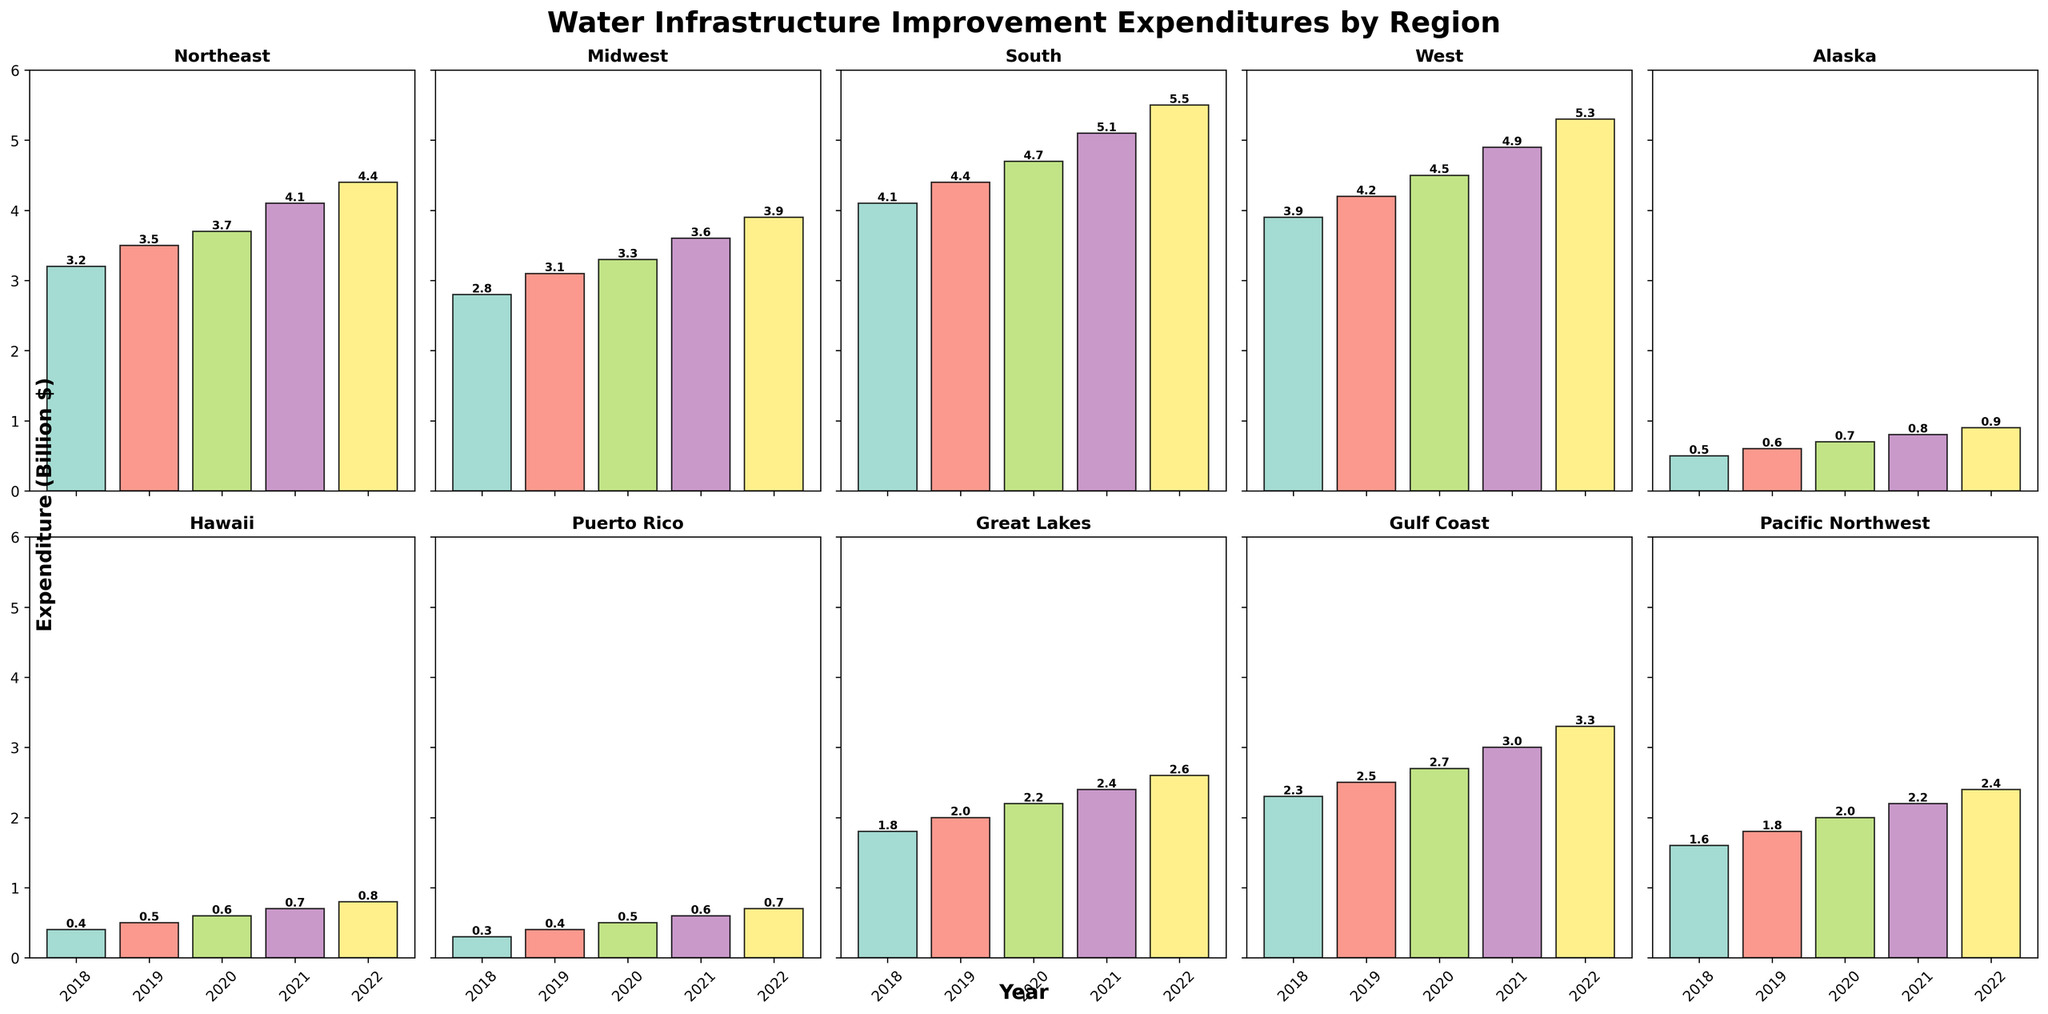Which region had the highest expenditure on water infrastructure improvements in 2022? To find the region with the highest expenditure in 2022, look at the height of the bars representing 2022 in all subplots. The tallest bar represents the highest expenditure. In the 2022 subplot, the South region has the tallest bar reaching 5.5.
Answer: South Which region had the lowest average expenditure from 2018 to 2022? Calculate the average expenditure for each region by summing the 2018-2022 values and dividing by 5. Then compare all averages. For example, for Alaska: (0.5 + 0.6 + 0.7 + 0.8 + 0.9) / 5 = 0.7, and do the same for all regions. The average for Puerto Rico is the lowest at (0.3 + 0.4 + 0.5 + 0.6 + 0.7)/5 = 0.5.
Answer: Puerto Rico How much did the expenditure increase in the Midwest region from 2018 to 2022? To find the increase, subtract the 2018 value from the 2022 value for the Midwest region: 3.9 - 2.8 = 1.1.
Answer: 1.1 billion $ What is the total expenditure of the West region from 2018 to 2022? Sum all the expenditures for the West region from 2018 to 2022: 3.9 + 4.2 + 4.5 + 4.9 + 5.3 = 22.8.
Answer: 22.8 billion $ Which region had a higher expenditure in 2020, the Great Lakes or Pacific Northwest? Compare the heights of the bars for 2020 for both the Great Lakes and Pacific Northwest regions. Great Lakes has 2.2 and Pacific Northwest has 2.0.
Answer: Great Lakes Was the expenditure in Hawaii higher in 2021 or 2019? Compare the heights of the bars for Hawaii in 2019 and 2021. In 2019, it is 0.5 and in 2021, it is 0.7.
Answer: 2021 Which region's expenditure showed the most significant growth from 2018 to 2022? Compare the difference between 2018 and 2022 values for each region and find the largest. For the South, it's 5.5 - 4.1 = 1.4, which shows the highest growth.
Answer: South What is the average expenditure of the Gulf Coast region from 2020 to 2022? Calculate the average of the Gulf Coast region for 2020, 2021, and 2022: (2.7 + 3.0 + 3.3) / 3 = 3.0.
Answer: 3.0 billion $ Which regions had expenditures lower than the Northeast in 2021? Compare the 2021 value (4.1) for the Northeast with values of other regions in 2021. The regions with lower expenditures are Alaska (0.8), Hawaii (0.7), Puerto Rico (0.6), Great Lakes (2.4), Gulf Coast (3.0), and Pacific Northwest (2.2).
Answer: Alaska, Hawaii, Puerto Rico, Great Lakes, Gulf Coast, Pacific Northwest How much did the expenditure in the Pacific Northwest region increase between 2019 and 2021? Subtract the 2019 expenditure from the 2021 expenditure for the Pacific Northwest: 2.2 - 1.8 = 0.4.
Answer: 0.4 billion $ 